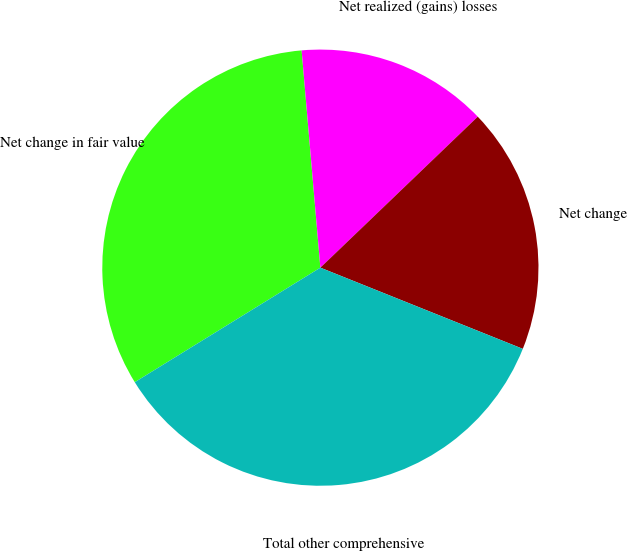Convert chart to OTSL. <chart><loc_0><loc_0><loc_500><loc_500><pie_chart><fcel>Net change in fair value<fcel>Net realized (gains) losses<fcel>Net change<fcel>Total other comprehensive<nl><fcel>32.43%<fcel>14.2%<fcel>18.24%<fcel>35.13%<nl></chart> 